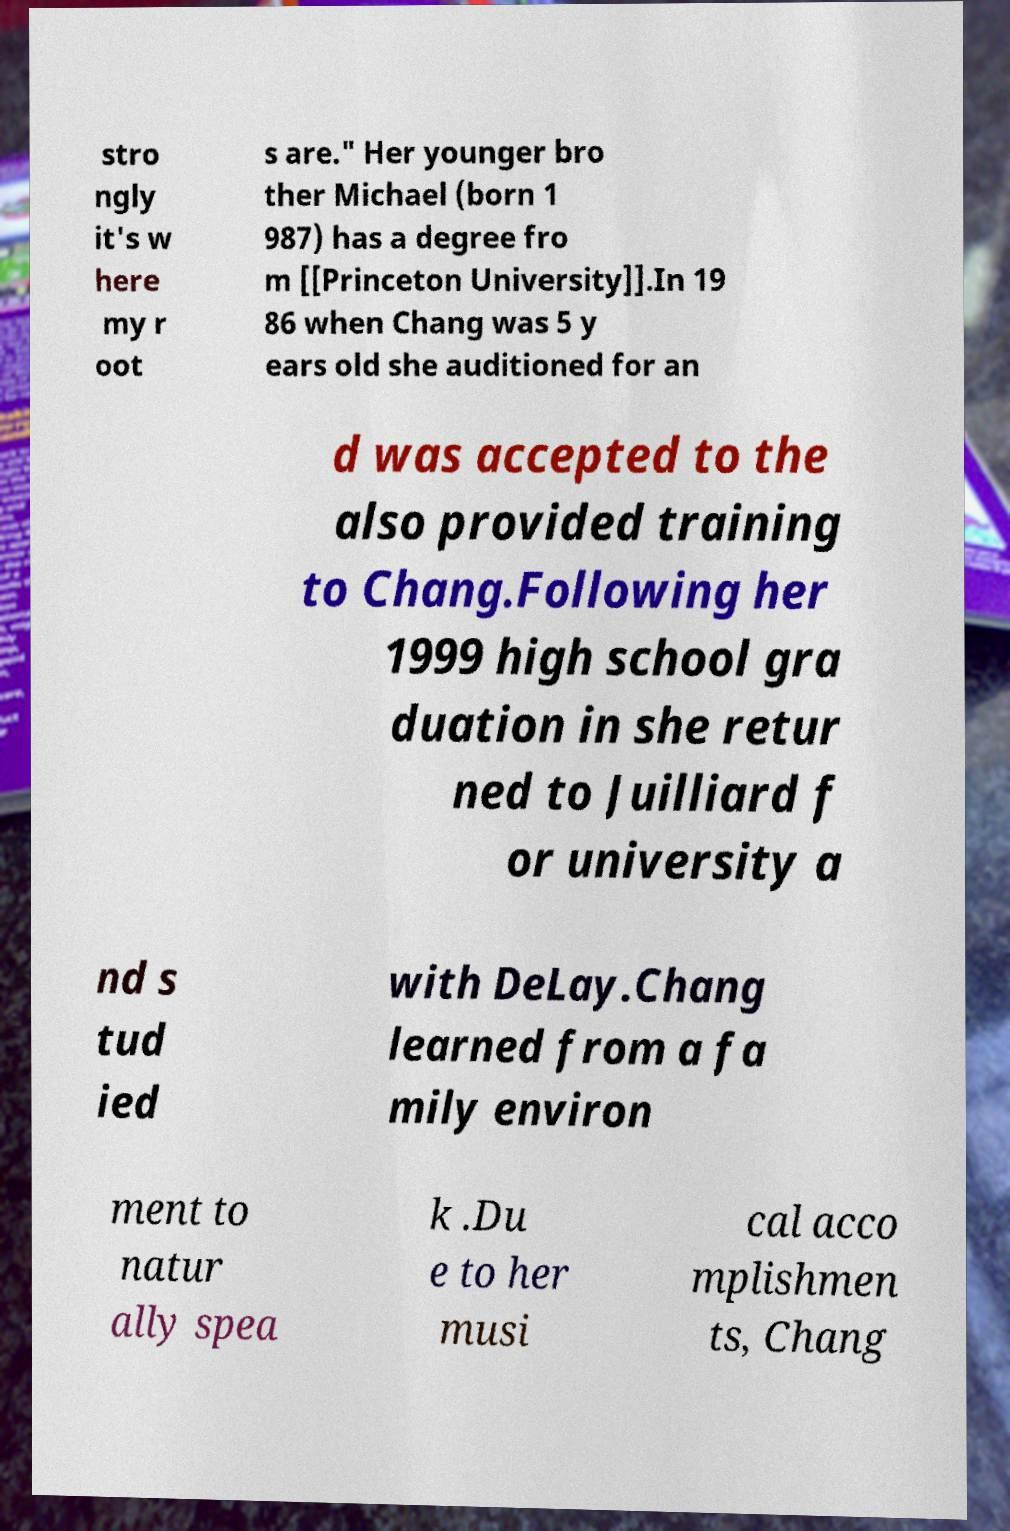Can you accurately transcribe the text from the provided image for me? stro ngly it's w here my r oot s are." Her younger bro ther Michael (born 1 987) has a degree fro m [[Princeton University]].In 19 86 when Chang was 5 y ears old she auditioned for an d was accepted to the also provided training to Chang.Following her 1999 high school gra duation in she retur ned to Juilliard f or university a nd s tud ied with DeLay.Chang learned from a fa mily environ ment to natur ally spea k .Du e to her musi cal acco mplishmen ts, Chang 